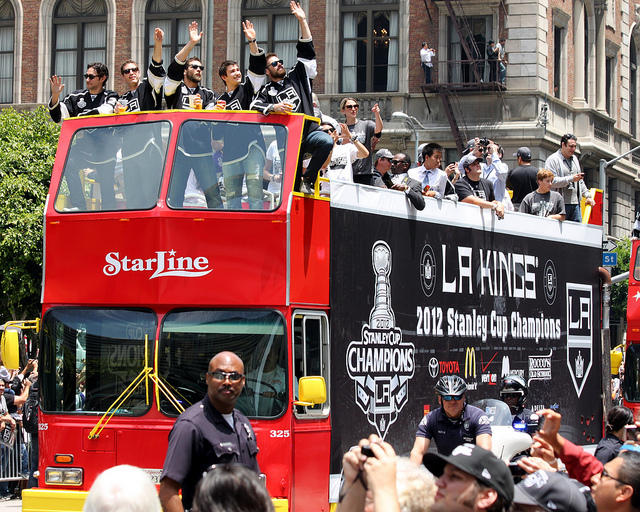Identify the text displayed in this image. Star Jine LAKINGS LA 2012 325 LA CHAMPIONS TOYOTA M Chanpions CUP Stanley C 